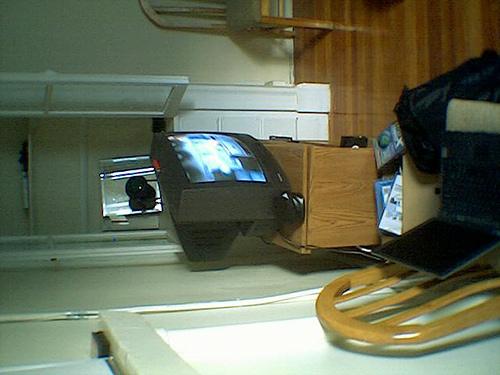Is this indoors?
Quick response, please. Yes. What's wrong with this picture?
Keep it brief. Sideways. Is there a laptop in the photo?
Concise answer only. No. 